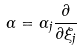Convert formula to latex. <formula><loc_0><loc_0><loc_500><loc_500>\Gamma = \Gamma _ { j } \frac { \partial } { \partial \xi _ { j } }</formula> 